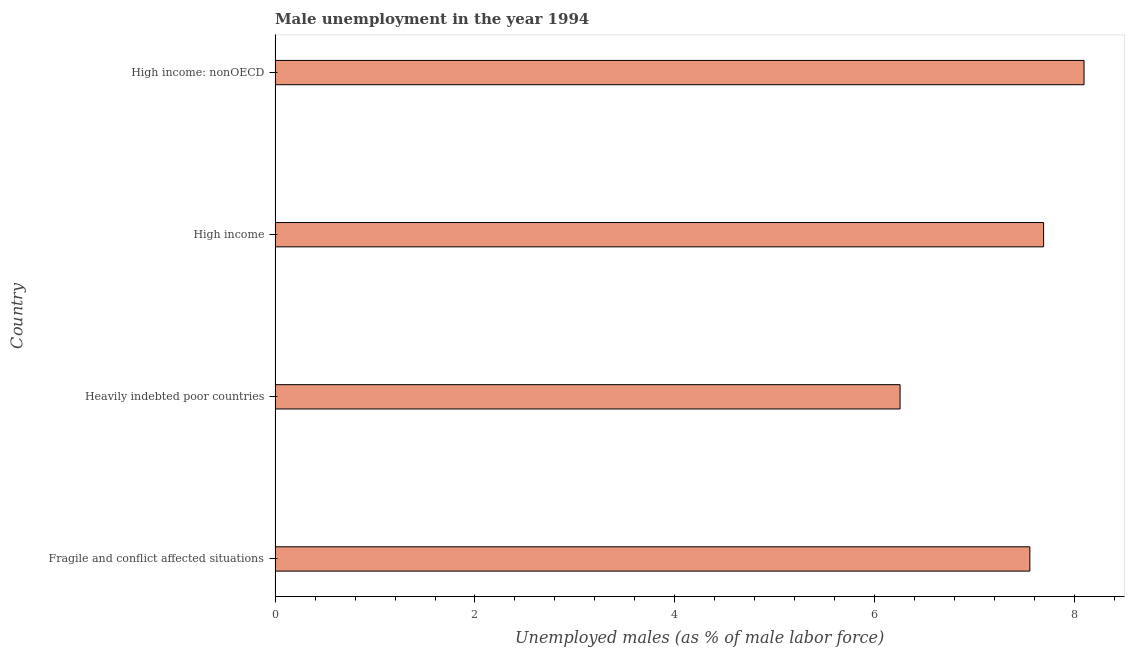Does the graph contain any zero values?
Provide a succinct answer. No. What is the title of the graph?
Give a very brief answer. Male unemployment in the year 1994. What is the label or title of the X-axis?
Your answer should be compact. Unemployed males (as % of male labor force). What is the label or title of the Y-axis?
Provide a succinct answer. Country. What is the unemployed males population in Heavily indebted poor countries?
Your answer should be very brief. 6.25. Across all countries, what is the maximum unemployed males population?
Provide a short and direct response. 8.09. Across all countries, what is the minimum unemployed males population?
Keep it short and to the point. 6.25. In which country was the unemployed males population maximum?
Keep it short and to the point. High income: nonOECD. In which country was the unemployed males population minimum?
Offer a very short reply. Heavily indebted poor countries. What is the sum of the unemployed males population?
Your answer should be compact. 29.59. What is the difference between the unemployed males population in Heavily indebted poor countries and High income?
Keep it short and to the point. -1.44. What is the average unemployed males population per country?
Make the answer very short. 7.4. What is the median unemployed males population?
Give a very brief answer. 7.62. In how many countries, is the unemployed males population greater than 5.2 %?
Provide a short and direct response. 4. What is the ratio of the unemployed males population in Heavily indebted poor countries to that in High income: nonOECD?
Provide a succinct answer. 0.77. What is the difference between the highest and the second highest unemployed males population?
Offer a terse response. 0.41. What is the difference between the highest and the lowest unemployed males population?
Make the answer very short. 1.84. Are the values on the major ticks of X-axis written in scientific E-notation?
Your answer should be compact. No. What is the Unemployed males (as % of male labor force) in Fragile and conflict affected situations?
Your answer should be compact. 7.55. What is the Unemployed males (as % of male labor force) of Heavily indebted poor countries?
Give a very brief answer. 6.25. What is the Unemployed males (as % of male labor force) in High income?
Make the answer very short. 7.69. What is the Unemployed males (as % of male labor force) in High income: nonOECD?
Your answer should be very brief. 8.09. What is the difference between the Unemployed males (as % of male labor force) in Fragile and conflict affected situations and Heavily indebted poor countries?
Give a very brief answer. 1.3. What is the difference between the Unemployed males (as % of male labor force) in Fragile and conflict affected situations and High income?
Offer a terse response. -0.14. What is the difference between the Unemployed males (as % of male labor force) in Fragile and conflict affected situations and High income: nonOECD?
Ensure brevity in your answer.  -0.54. What is the difference between the Unemployed males (as % of male labor force) in Heavily indebted poor countries and High income?
Your answer should be very brief. -1.44. What is the difference between the Unemployed males (as % of male labor force) in Heavily indebted poor countries and High income: nonOECD?
Your answer should be very brief. -1.84. What is the difference between the Unemployed males (as % of male labor force) in High income and High income: nonOECD?
Provide a short and direct response. -0.4. What is the ratio of the Unemployed males (as % of male labor force) in Fragile and conflict affected situations to that in Heavily indebted poor countries?
Offer a very short reply. 1.21. What is the ratio of the Unemployed males (as % of male labor force) in Fragile and conflict affected situations to that in High income?
Give a very brief answer. 0.98. What is the ratio of the Unemployed males (as % of male labor force) in Fragile and conflict affected situations to that in High income: nonOECD?
Provide a short and direct response. 0.93. What is the ratio of the Unemployed males (as % of male labor force) in Heavily indebted poor countries to that in High income?
Your answer should be very brief. 0.81. What is the ratio of the Unemployed males (as % of male labor force) in Heavily indebted poor countries to that in High income: nonOECD?
Offer a terse response. 0.77. What is the ratio of the Unemployed males (as % of male labor force) in High income to that in High income: nonOECD?
Offer a very short reply. 0.95. 